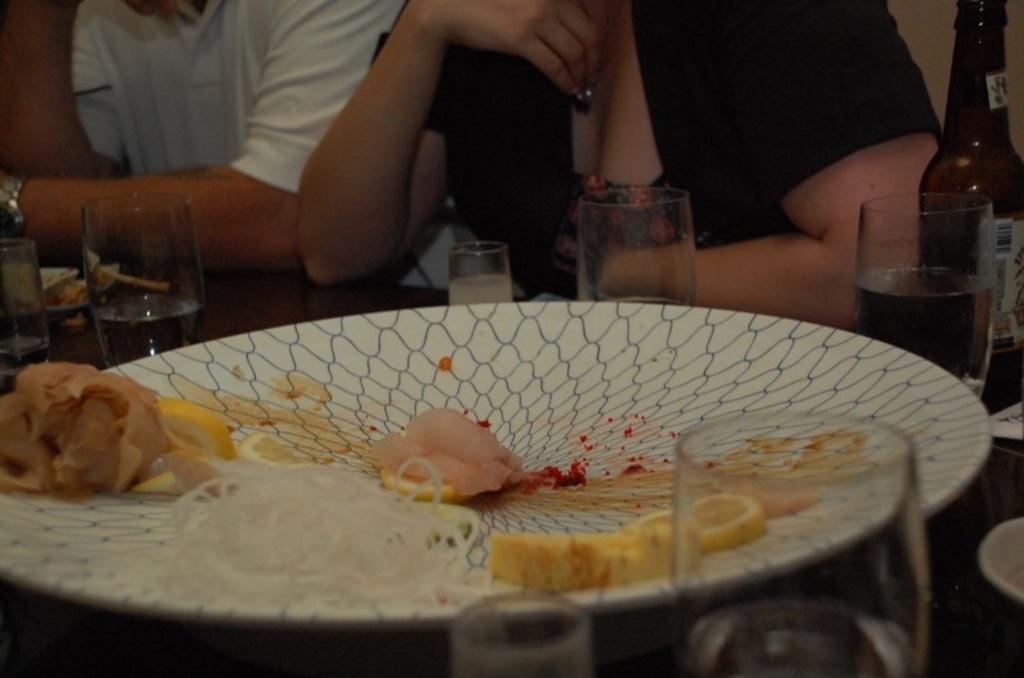Could you give a brief overview of what you see in this image? This image consists of a plate, glass, bottle on the right side. There are eatables on the plate. There are two persons on the top. One is man other one is woman. Man is wearing white shirt, woman is wearing black shirt. 